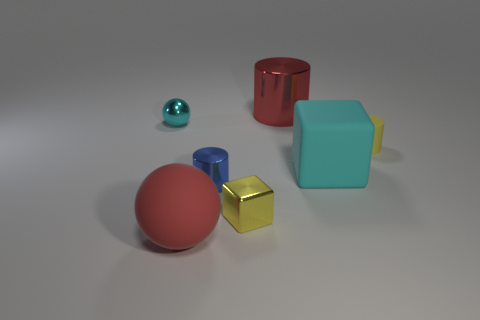The blue object has what size?
Provide a short and direct response. Small. What is the shape of the red object that is in front of the tiny matte cylinder?
Offer a very short reply. Sphere. Is the shape of the small cyan thing the same as the tiny yellow metallic thing?
Your answer should be very brief. No. Are there an equal number of yellow cylinders that are to the right of the yellow rubber object and large cyan matte cylinders?
Your answer should be compact. Yes. What is the shape of the tiny yellow matte object?
Give a very brief answer. Cylinder. Is there anything else that is the same color as the tiny metal cylinder?
Ensure brevity in your answer.  No. There is a yellow object behind the large cube; is its size the same as the shiny object behind the small cyan shiny object?
Provide a short and direct response. No. There is a cyan thing to the right of the sphere in front of the large cyan thing; what is its shape?
Provide a short and direct response. Cube. Is the size of the metallic ball the same as the shiny cylinder in front of the cyan metallic sphere?
Make the answer very short. Yes. There is a block left of the large red metallic object that is behind the cyan thing on the left side of the big cyan cube; what is its size?
Your answer should be compact. Small. 